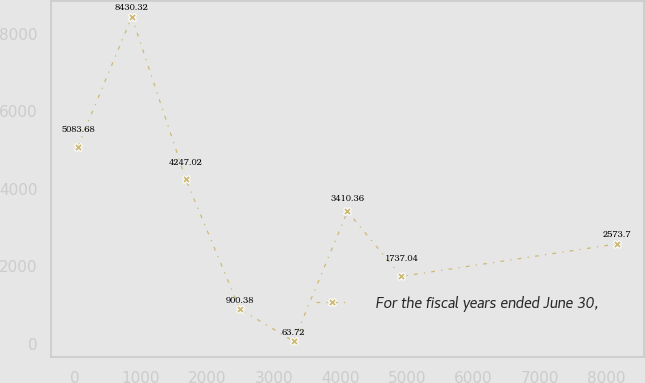<chart> <loc_0><loc_0><loc_500><loc_500><line_chart><ecel><fcel>For the fiscal years ended June 30,<nl><fcel>50.19<fcel>5083.68<nl><fcel>861.51<fcel>8430.32<nl><fcel>1672.83<fcel>4247.02<nl><fcel>2484.15<fcel>900.38<nl><fcel>3295.47<fcel>63.72<nl><fcel>4106.79<fcel>3410.36<nl><fcel>4918.11<fcel>1737.04<nl><fcel>8163.42<fcel>2573.7<nl></chart> 